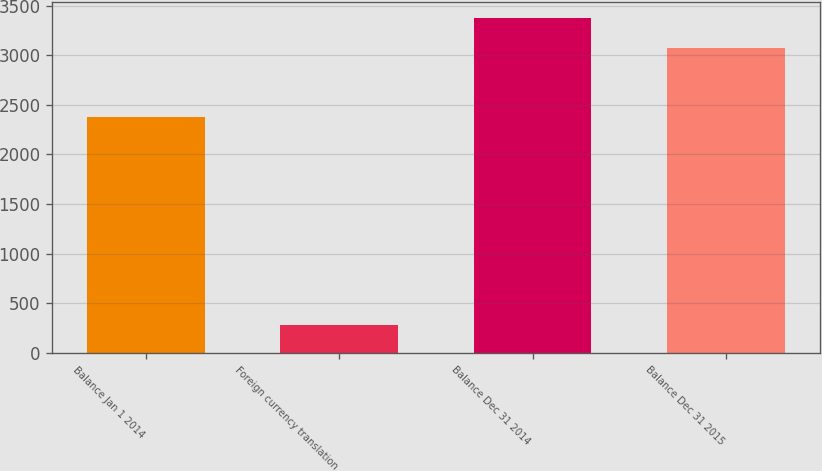Convert chart to OTSL. <chart><loc_0><loc_0><loc_500><loc_500><bar_chart><fcel>Balance Jan 1 2014<fcel>Foreign currency translation<fcel>Balance Dec 31 2014<fcel>Balance Dec 31 2015<nl><fcel>2381<fcel>279<fcel>3371.8<fcel>3073<nl></chart> 